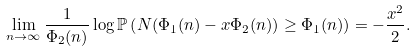Convert formula to latex. <formula><loc_0><loc_0><loc_500><loc_500>\lim _ { n \rightarrow \infty } \frac { 1 } { \Phi _ { 2 } ( n ) } \log \mathbb { P } \left ( N ( \Phi _ { 1 } ( n ) - x \Phi _ { 2 } ( n ) ) \geq \Phi _ { 1 } ( n ) \right ) = - \frac { x ^ { 2 } } { 2 } .</formula> 